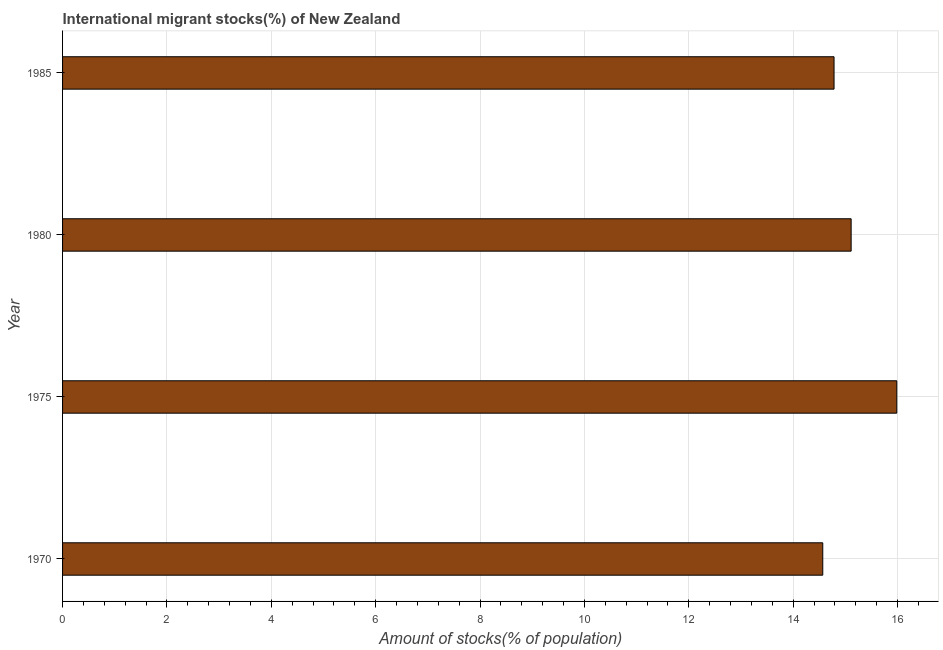Does the graph contain grids?
Offer a terse response. Yes. What is the title of the graph?
Offer a very short reply. International migrant stocks(%) of New Zealand. What is the label or title of the X-axis?
Offer a very short reply. Amount of stocks(% of population). What is the number of international migrant stocks in 1980?
Your answer should be compact. 15.11. Across all years, what is the maximum number of international migrant stocks?
Offer a terse response. 15.99. Across all years, what is the minimum number of international migrant stocks?
Keep it short and to the point. 14.57. In which year was the number of international migrant stocks maximum?
Make the answer very short. 1975. What is the sum of the number of international migrant stocks?
Ensure brevity in your answer.  60.45. What is the difference between the number of international migrant stocks in 1970 and 1980?
Ensure brevity in your answer.  -0.54. What is the average number of international migrant stocks per year?
Make the answer very short. 15.11. What is the median number of international migrant stocks?
Give a very brief answer. 14.95. What is the ratio of the number of international migrant stocks in 1975 to that in 1985?
Give a very brief answer. 1.08. Is the difference between the number of international migrant stocks in 1980 and 1985 greater than the difference between any two years?
Keep it short and to the point. No. Is the sum of the number of international migrant stocks in 1975 and 1985 greater than the maximum number of international migrant stocks across all years?
Keep it short and to the point. Yes. What is the difference between the highest and the lowest number of international migrant stocks?
Make the answer very short. 1.42. In how many years, is the number of international migrant stocks greater than the average number of international migrant stocks taken over all years?
Your response must be concise. 1. How many bars are there?
Ensure brevity in your answer.  4. Are all the bars in the graph horizontal?
Provide a succinct answer. Yes. What is the difference between two consecutive major ticks on the X-axis?
Provide a short and direct response. 2. What is the Amount of stocks(% of population) of 1970?
Ensure brevity in your answer.  14.57. What is the Amount of stocks(% of population) in 1975?
Keep it short and to the point. 15.99. What is the Amount of stocks(% of population) in 1980?
Give a very brief answer. 15.11. What is the Amount of stocks(% of population) of 1985?
Your answer should be compact. 14.78. What is the difference between the Amount of stocks(% of population) in 1970 and 1975?
Provide a short and direct response. -1.42. What is the difference between the Amount of stocks(% of population) in 1970 and 1980?
Ensure brevity in your answer.  -0.54. What is the difference between the Amount of stocks(% of population) in 1970 and 1985?
Give a very brief answer. -0.22. What is the difference between the Amount of stocks(% of population) in 1975 and 1980?
Your answer should be compact. 0.87. What is the difference between the Amount of stocks(% of population) in 1975 and 1985?
Your answer should be very brief. 1.2. What is the difference between the Amount of stocks(% of population) in 1980 and 1985?
Offer a very short reply. 0.33. What is the ratio of the Amount of stocks(% of population) in 1970 to that in 1975?
Offer a terse response. 0.91. What is the ratio of the Amount of stocks(% of population) in 1970 to that in 1985?
Offer a terse response. 0.98. What is the ratio of the Amount of stocks(% of population) in 1975 to that in 1980?
Make the answer very short. 1.06. What is the ratio of the Amount of stocks(% of population) in 1975 to that in 1985?
Offer a terse response. 1.08. 